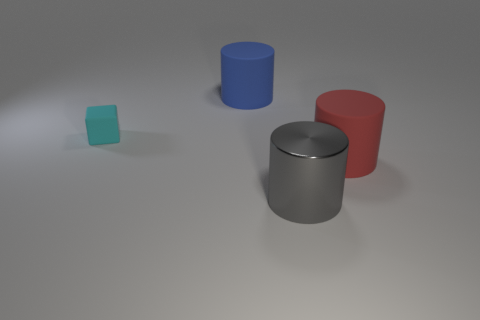Subtract all large rubber cylinders. How many cylinders are left? 1 Add 3 small cyan cubes. How many objects exist? 7 Subtract all cylinders. How many objects are left? 1 Subtract 0 red spheres. How many objects are left? 4 Subtract all blue rubber cylinders. Subtract all rubber cubes. How many objects are left? 2 Add 4 big red rubber cylinders. How many big red rubber cylinders are left? 5 Add 1 small matte objects. How many small matte objects exist? 2 